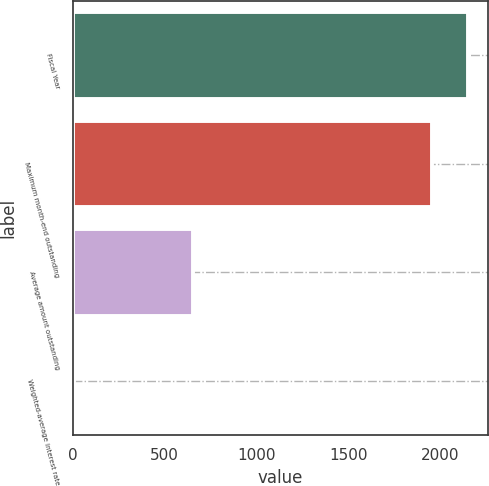<chart> <loc_0><loc_0><loc_500><loc_500><bar_chart><fcel>Fiscal Year<fcel>Maximum month-end outstanding<fcel>Average amount outstanding<fcel>Weighted-average interest rate<nl><fcel>2155.35<fcel>1955<fcel>655<fcel>4.5<nl></chart> 